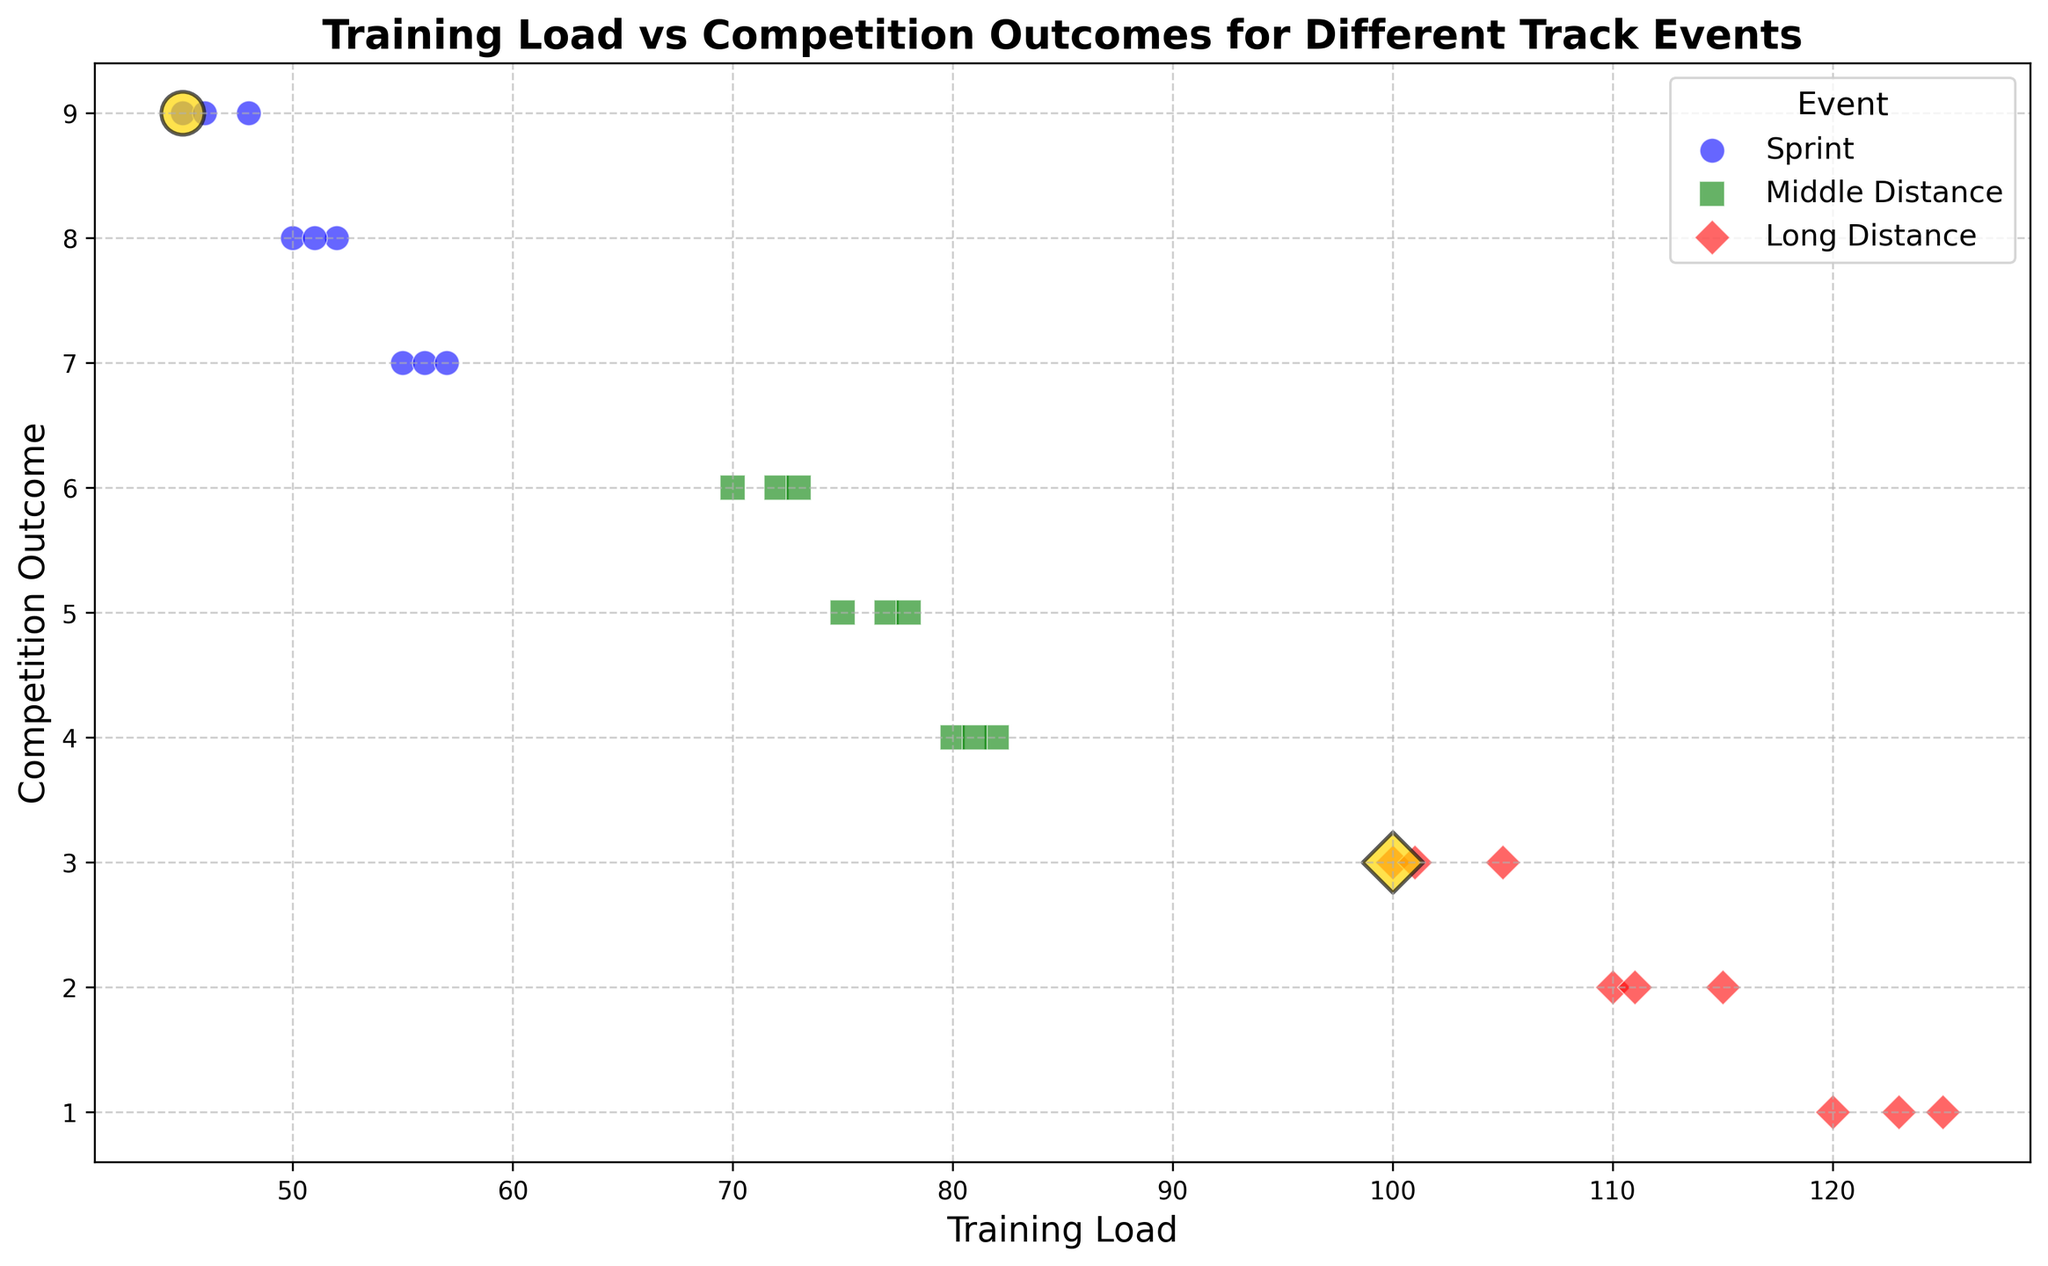What color are the bubbles for the 'Sprint' event? The 'Sprint' event is represented by blue bubbles.
Answer: blue How many athletes are there whose bubble color is red? Red bubbles represent the 'Long Distance' event. Counting the unique athletes in the 'Long Distance' category, there are 9 athletes: Nils Voigt, Emma White, David Black, Mark Silver, Nina Gold, Oscar Bronze, Karen Yellow, Larry Beige, and Olivia Cerulean.
Answer: 9 Which group has the highest training load? By observing the x-axis (training load), the 'Long Distance' group shows the highest training loads (ranging from 100 to 125).
Answer: Long Distance What are the competition outcomes associated with athletes having a training load of 50? Referring to the x-axis for a training load of 50, there is one data point belonging to the 'Sprint' event with a competition outcome of 8.
Answer: 8 How does Nils Voigt's training load compare between the Sprint and Long Distance events? Nils Voigt has two data points. For the 'Sprint' event, his training load is 45, and for the 'Long Distance' event, it is 100. The Long Distance training load is higher.
Answer: Long Distance is higher Which event does the gold-colored bubble represent? The gold-colored bubble specifically highlights Nils Voigt. Nils Voigt participates in both the 'Sprint' and 'Long Distance' events, so both events are represented by gold, but the bubble marker and corresponding event can be distinguished based on the event markers (o for Sprint and D for Long Distance).
Answer: Sprint and Long Distance Which athlete has the lowest competition outcome in the 'Long Distance' event? The lowest competition outcome in the 'Long Distance' event is 1. Finding the corresponding athletes for this outcome, they are David Black and Oscar Bronze.
Answer: David Black and Oscar Bronze What is the average training load for athletes in the 'Middle Distance' group? Middle Distance athletes have training loads of 70, 75, 80, 72, 77, 82, 73, 78, and 81. Summing these values, (70 + 75 + 80 + 72 + 77 + 82 + 73 + 78 + 81) = 688. The average training load is 688/9 = 76.44.
Answer: 76.44 Which event shows more variability in competition outcomes? Variability can be assessed by the spread of competition outcomes along the y-axis. 'Sprint' outcomes range from 7 to 9, 'Middle Distance' range from 4 to 6, and 'Long Distance' range from 1 to 3. Therefore, 'Sprint' has a broader range and shows more variability.
Answer: Sprint 